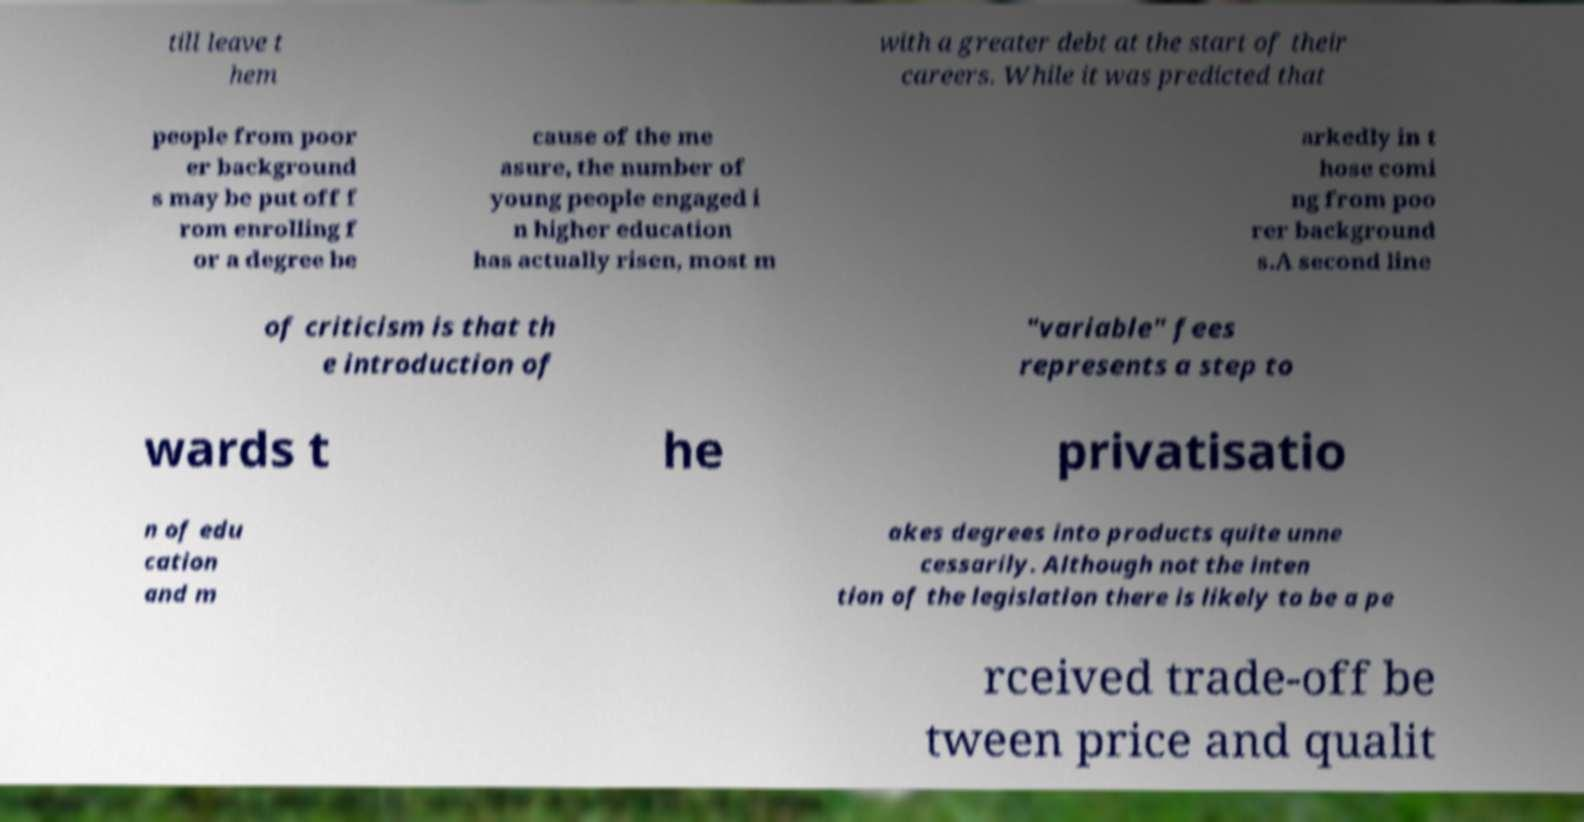Please identify and transcribe the text found in this image. till leave t hem with a greater debt at the start of their careers. While it was predicted that people from poor er background s may be put off f rom enrolling f or a degree be cause of the me asure, the number of young people engaged i n higher education has actually risen, most m arkedly in t hose comi ng from poo rer background s.A second line of criticism is that th e introduction of "variable" fees represents a step to wards t he privatisatio n of edu cation and m akes degrees into products quite unne cessarily. Although not the inten tion of the legislation there is likely to be a pe rceived trade-off be tween price and qualit 